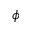Convert formula to latex. <formula><loc_0><loc_0><loc_500><loc_500>\phi</formula> 